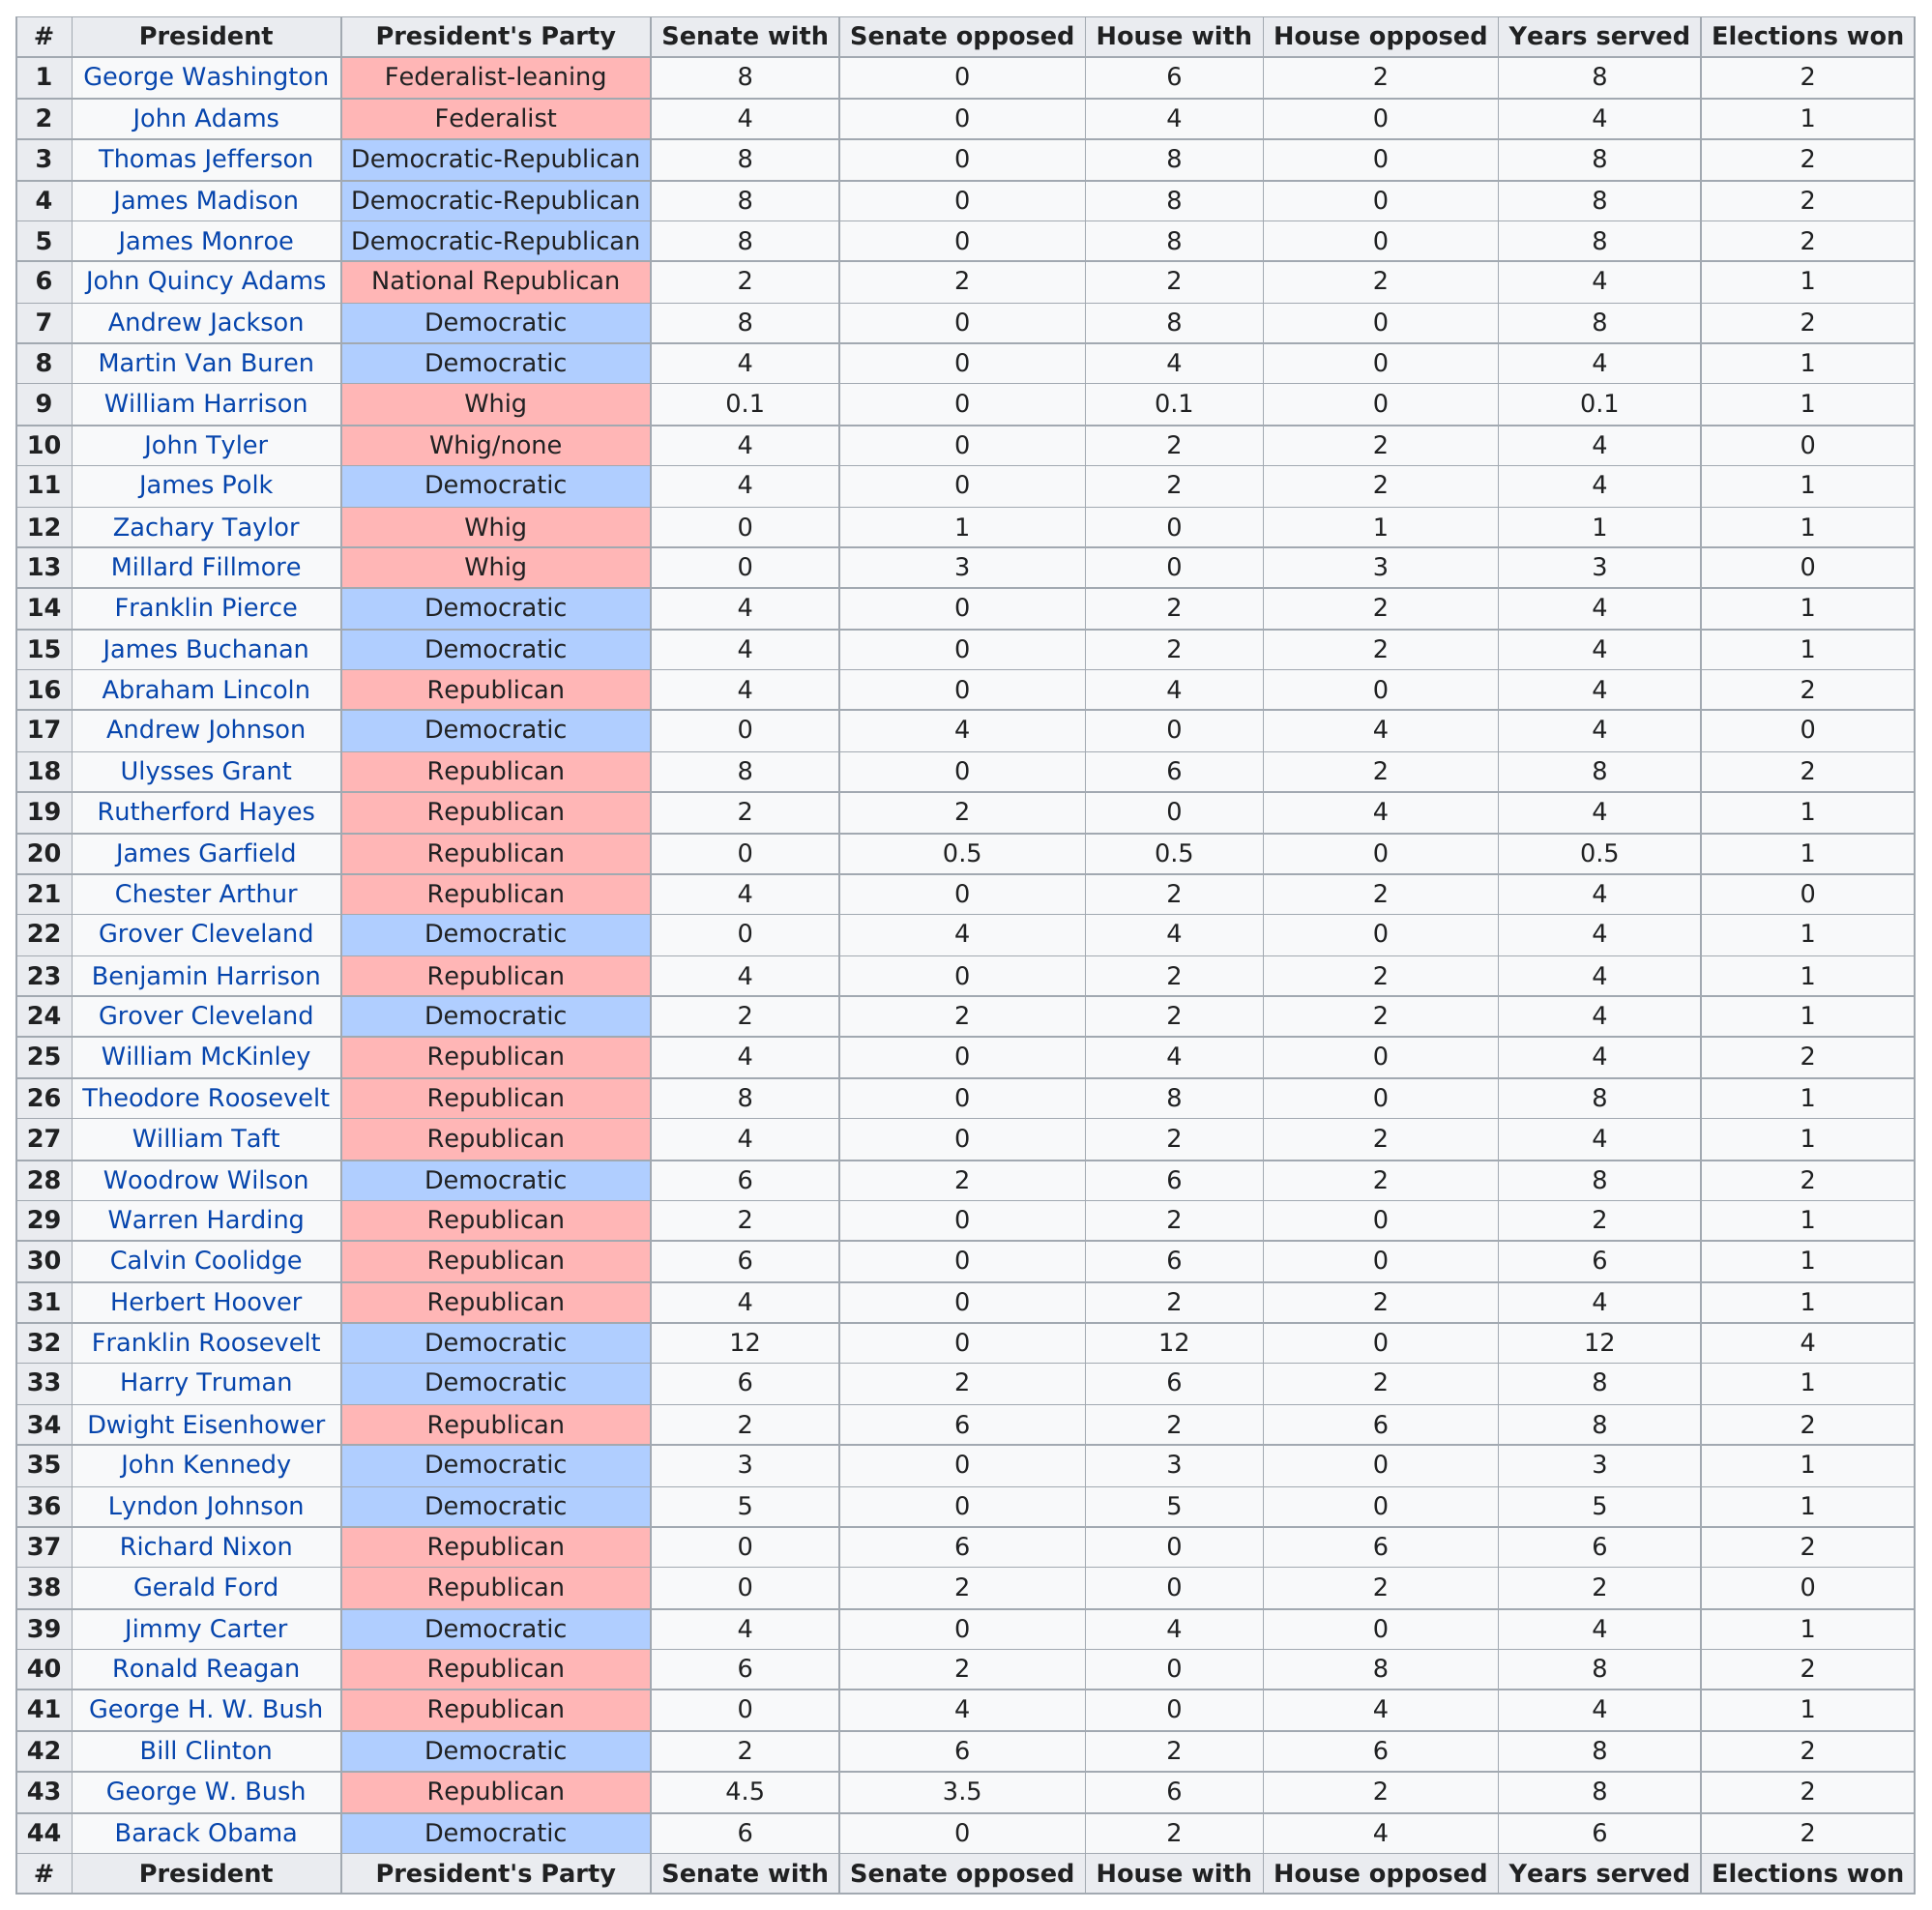Draw attention to some important aspects in this diagram. Andrew Johnson served a total of 4 years. The combined service of the first three presidents was 20 years. Four presidents were members of the Whig Party. William McKinley won two elections. John Adams was the only president who was able to match his senate and house support with his years served, achieving this unique feat. 